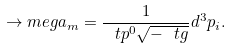<formula> <loc_0><loc_0><loc_500><loc_500>\to m e g a _ { m } = \frac { 1 } { \ t p ^ { 0 } \sqrt { - \ t g } } d ^ { 3 } p _ { i } .</formula> 